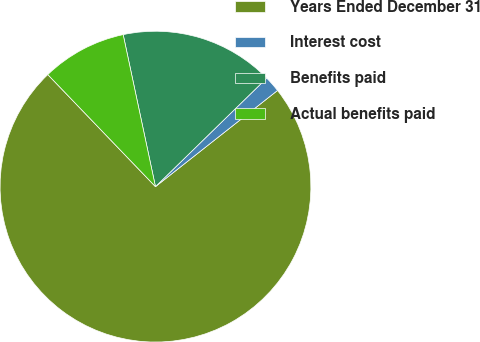<chart> <loc_0><loc_0><loc_500><loc_500><pie_chart><fcel>Years Ended December 31<fcel>Interest cost<fcel>Benefits paid<fcel>Actual benefits paid<nl><fcel>73.44%<fcel>1.68%<fcel>16.03%<fcel>8.85%<nl></chart> 